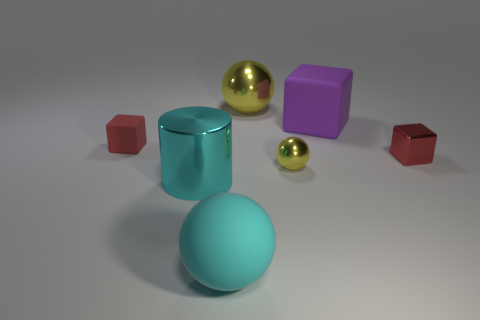What number of objects are yellow metallic objects that are to the right of the large metallic ball or tiny cubes?
Offer a very short reply. 3. The big metallic sphere is what color?
Make the answer very short. Yellow. What is the tiny red object that is left of the small red metallic block made of?
Offer a very short reply. Rubber. There is a small red matte thing; is it the same shape as the large metal thing that is behind the red metallic object?
Provide a short and direct response. No. Are there more cyan matte things than large blue cylinders?
Your answer should be very brief. Yes. Is there any other thing that is the same color as the large block?
Make the answer very short. No. What shape is the red object that is the same material as the cylinder?
Your response must be concise. Cube. The cube that is in front of the thing to the left of the cyan metal thing is made of what material?
Provide a short and direct response. Metal. There is a yellow shiny object in front of the large rubber cube; is it the same shape as the cyan rubber thing?
Make the answer very short. Yes. Are there more red matte blocks on the left side of the metal cylinder than small yellow blocks?
Provide a succinct answer. Yes. 